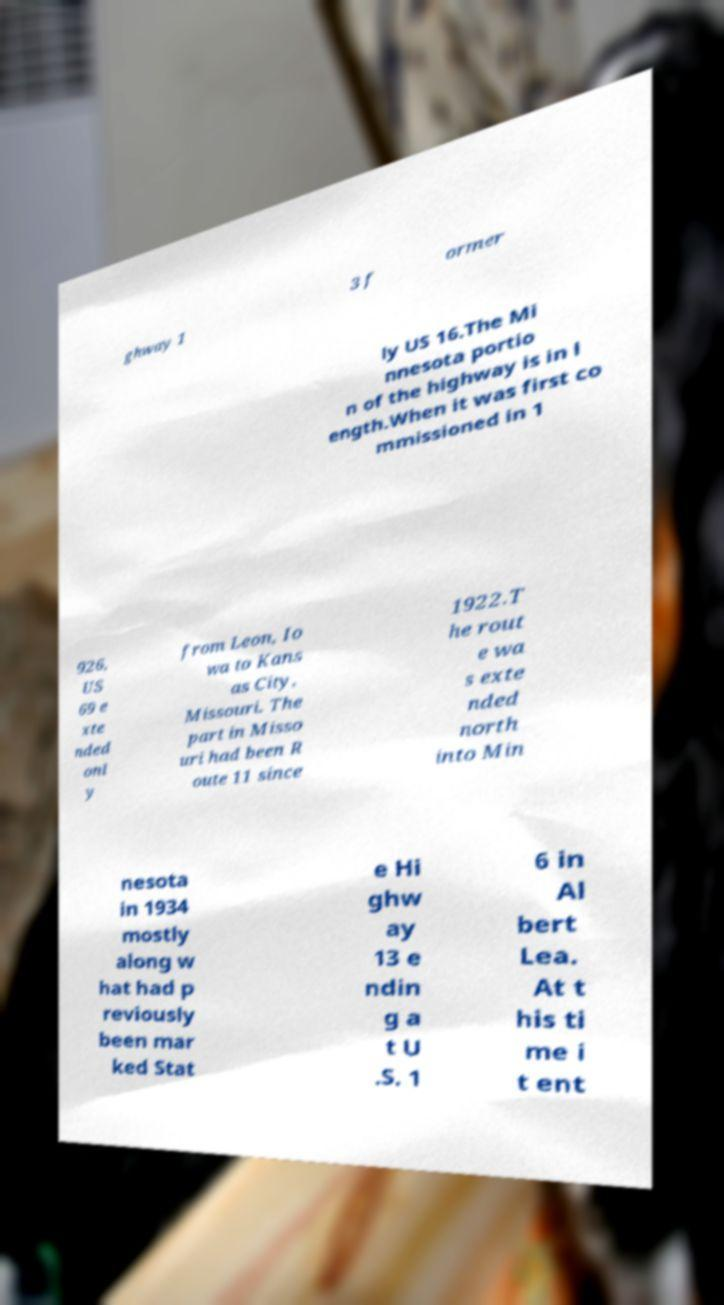Could you extract and type out the text from this image? ghway 1 3 f ormer ly US 16.The Mi nnesota portio n of the highway is in l ength.When it was first co mmissioned in 1 926, US 69 e xte nded onl y from Leon, Io wa to Kans as City, Missouri. The part in Misso uri had been R oute 11 since 1922.T he rout e wa s exte nded north into Min nesota in 1934 mostly along w hat had p reviously been mar ked Stat e Hi ghw ay 13 e ndin g a t U .S. 1 6 in Al bert Lea. At t his ti me i t ent 